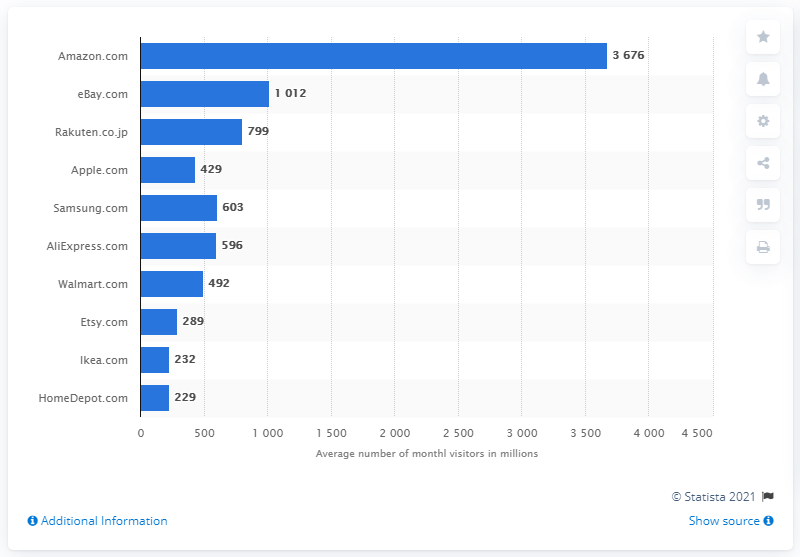Outline some significant characteristics in this image. In 2020, the average monthly traffic on Amazon was 3,676. 